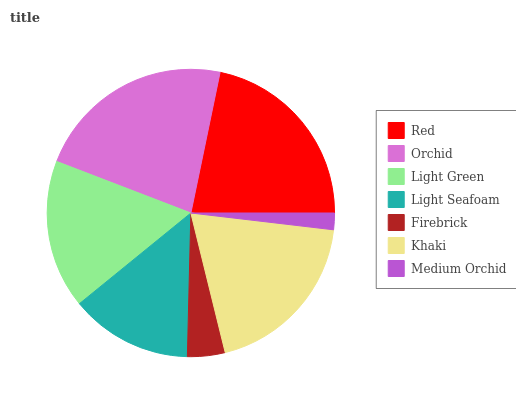Is Medium Orchid the minimum?
Answer yes or no. Yes. Is Orchid the maximum?
Answer yes or no. Yes. Is Light Green the minimum?
Answer yes or no. No. Is Light Green the maximum?
Answer yes or no. No. Is Orchid greater than Light Green?
Answer yes or no. Yes. Is Light Green less than Orchid?
Answer yes or no. Yes. Is Light Green greater than Orchid?
Answer yes or no. No. Is Orchid less than Light Green?
Answer yes or no. No. Is Light Green the high median?
Answer yes or no. Yes. Is Light Green the low median?
Answer yes or no. Yes. Is Orchid the high median?
Answer yes or no. No. Is Orchid the low median?
Answer yes or no. No. 